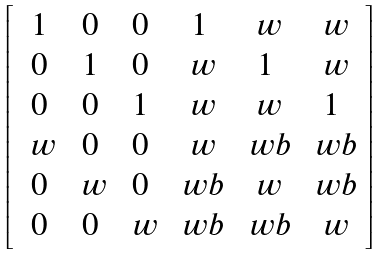Convert formula to latex. <formula><loc_0><loc_0><loc_500><loc_500>\left [ \begin{array} { c c c c c c } 1 & 0 & 0 & 1 & \ w & \ w \\ 0 & 1 & 0 & \ w & 1 & \ w \\ 0 & 0 & 1 & \ w & \ w & 1 \\ \ w & 0 & 0 & \ w & \ w b & \ w b \\ 0 & \ w & 0 & \ w b & \ w & \ w b \\ 0 & 0 & \ w & \ w b & \ w b & \ w \end{array} \right ]</formula> 